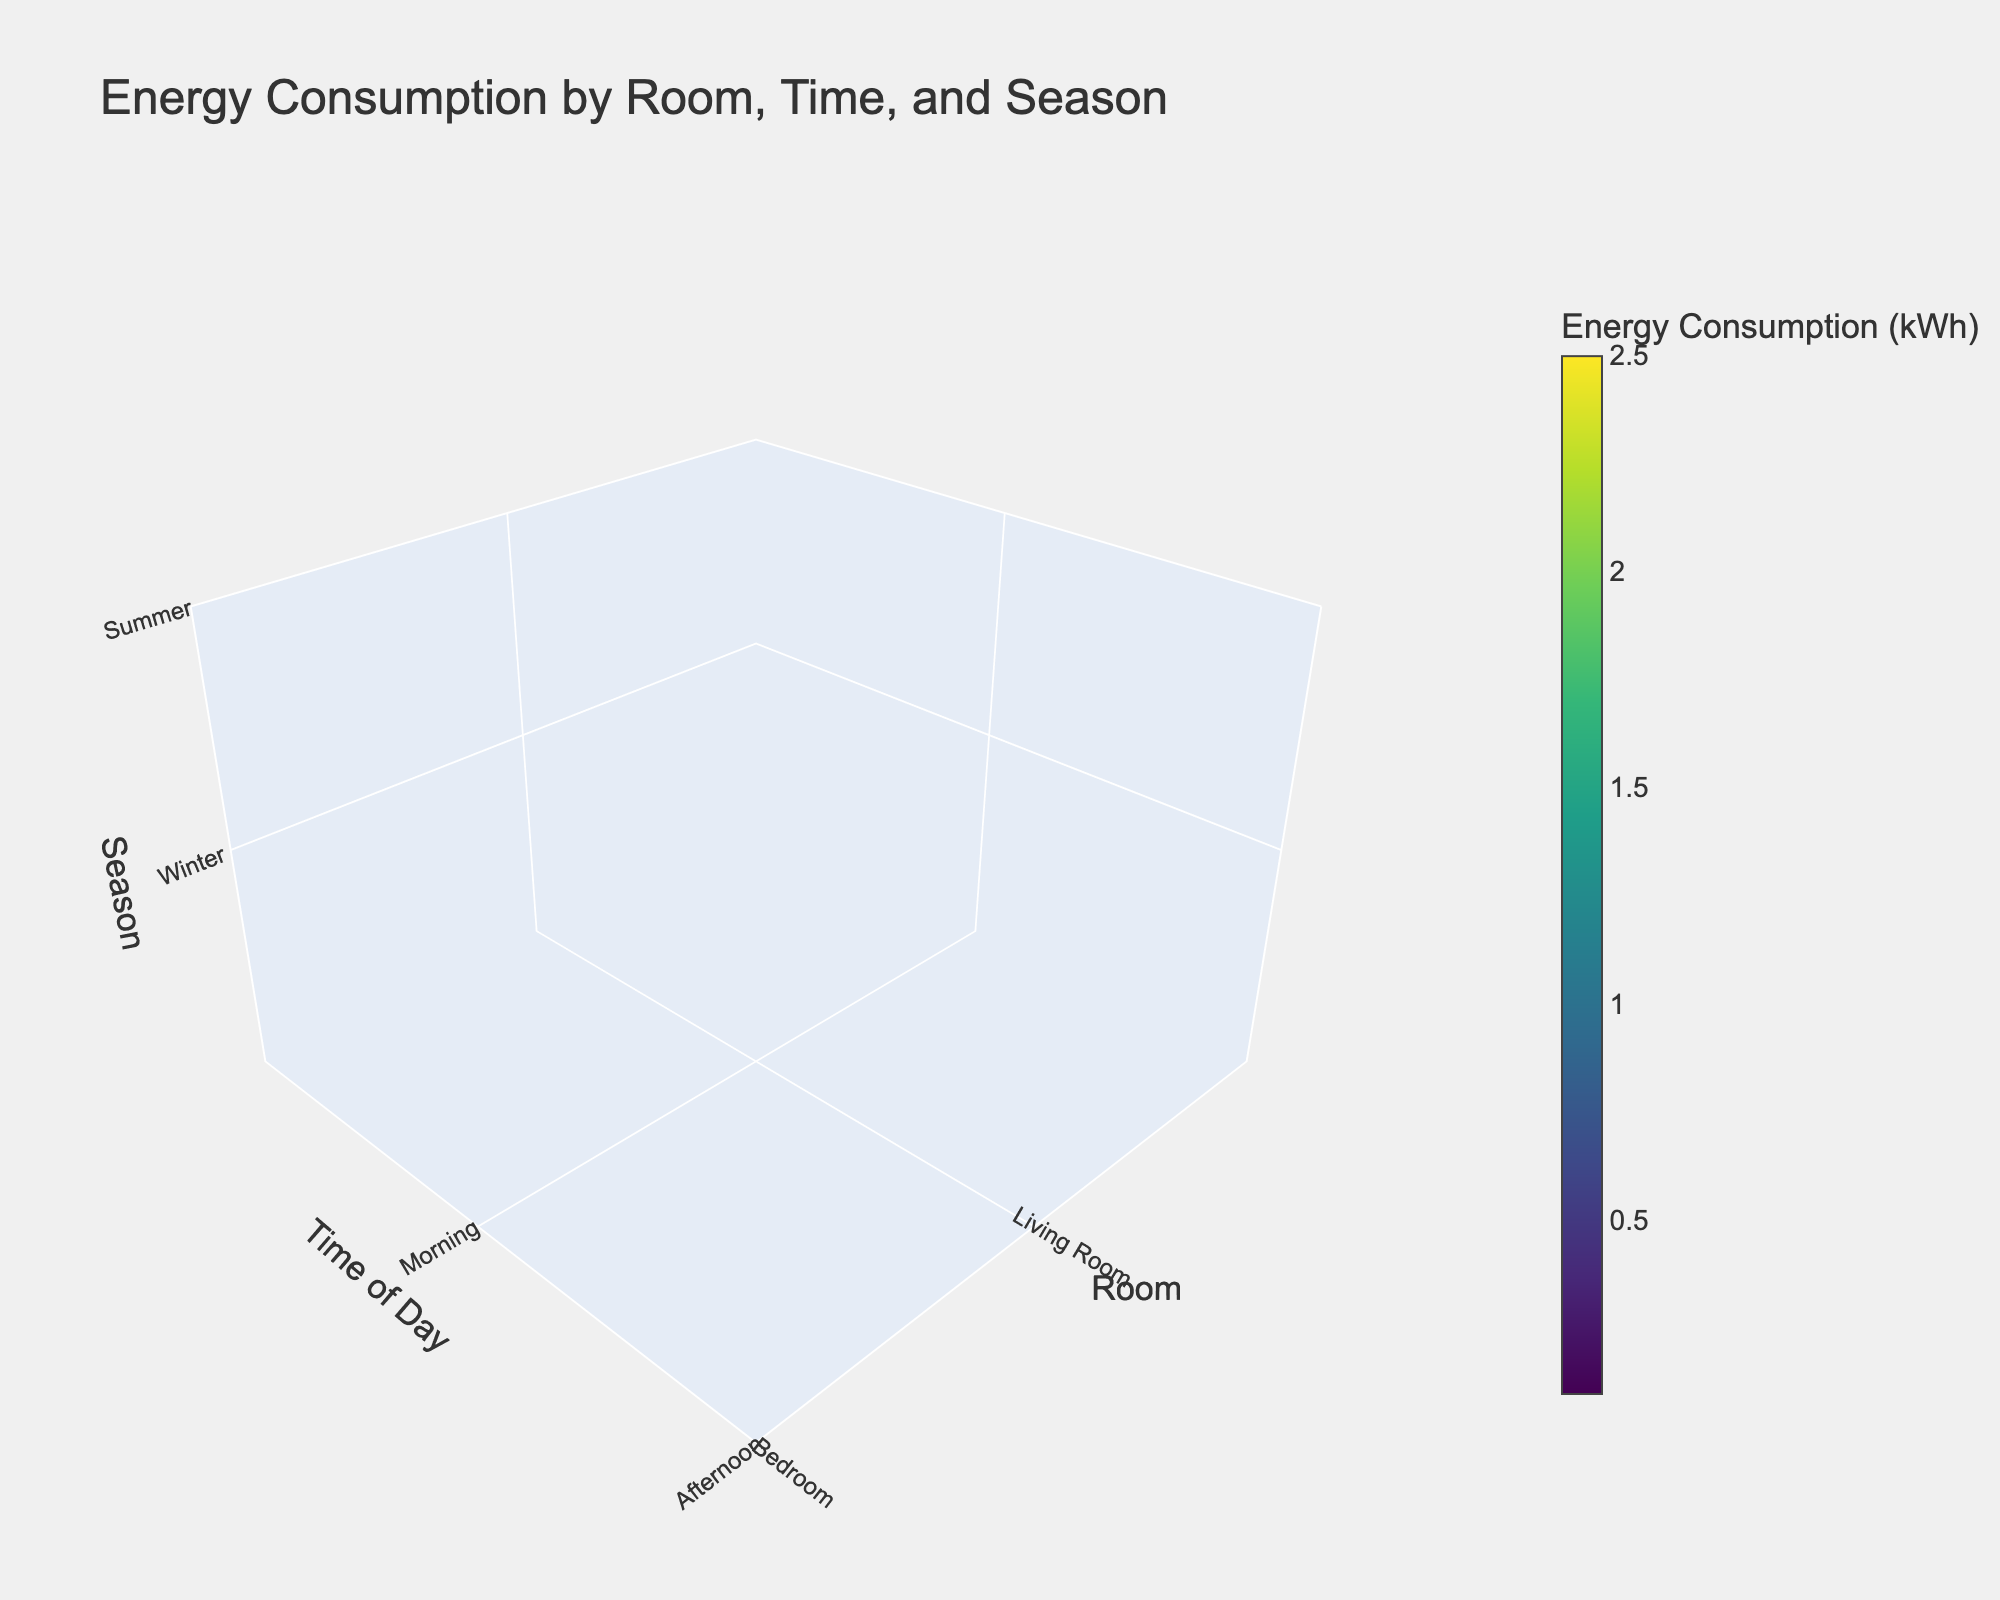What is the title of the figure? The title is displayed at the top center of the figure. Reading it directly provides the answer.
Answer: Energy Consumption by Room, Time, and Season What is the unit of measurement used for energy consumption in the figure? The unit of measurement is typically noted on the color bar, which indicates energy consumption values.
Answer: kWh Which room shows the highest energy consumption during the evening in winter? Find the section that corresponds to the evening time of day, winter season, and look for the highest value in the color bar within the different rooms.
Answer: Living Room Compare the energy consumption between the Living Room and the Kitchen during the morning in summer. Which one is higher? Identify the energy consumption values for the Living Room and the Kitchen during summer mornings by checking the color intensities and their corresponding values on the color bar.
Answer: Kitchen Which room has the lowest energy consumption at night during summer? Look for the night time of day, summer season, and find the room with the lowest value in energy consumption as indicated by the color bar.
Answer: Bathroom What is the average energy consumption for the Bedroom across all time periods in winter? Identify all energy consumption values for the Bedroom during winter from the color intensities, sum them up and divide by the number of values.
Answer: (0.4 + 0.2 + 1.0 + 0.6) / 4 = 0.55 kWh How does the energy consumption in the Kitchen in the evening during winter compare to that in the Living Room during the same period? Compare the energy consumption values for both rooms during the evening in winter, referring to the color bar for precise values.
Answer: The Kitchen's energy consumption (2.0 kWh) is lower than the Living Room's (2.5 kWh) Which time of day sees the highest energy consumption across all rooms and seasons combined? Analyze the color intensities for all rooms and seasons, and determine the time of day where the highest values appear most consistently.
Answer: Evening What are the seasonal differences in energy consumption in the Living Room during the afternoon? Compare the energy consumption values for the Living Room in the afternoon across winter and summer by referring to the color bar values.
Answer: Winter: 0.8 kWh, Summer: 1.5 kWh Which room has the most consistent energy consumption pattern throughout the day in summer? Look at the summer season and compare the energy consumption values across different times of day for each room to determine the most stable pattern.
Answer: Bathroom 